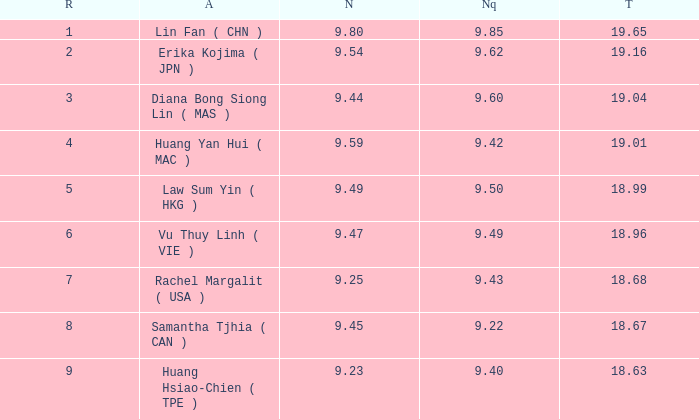Which Nanquan has a Nandao larger than 9.49, and a Rank of 4? 9.42. 